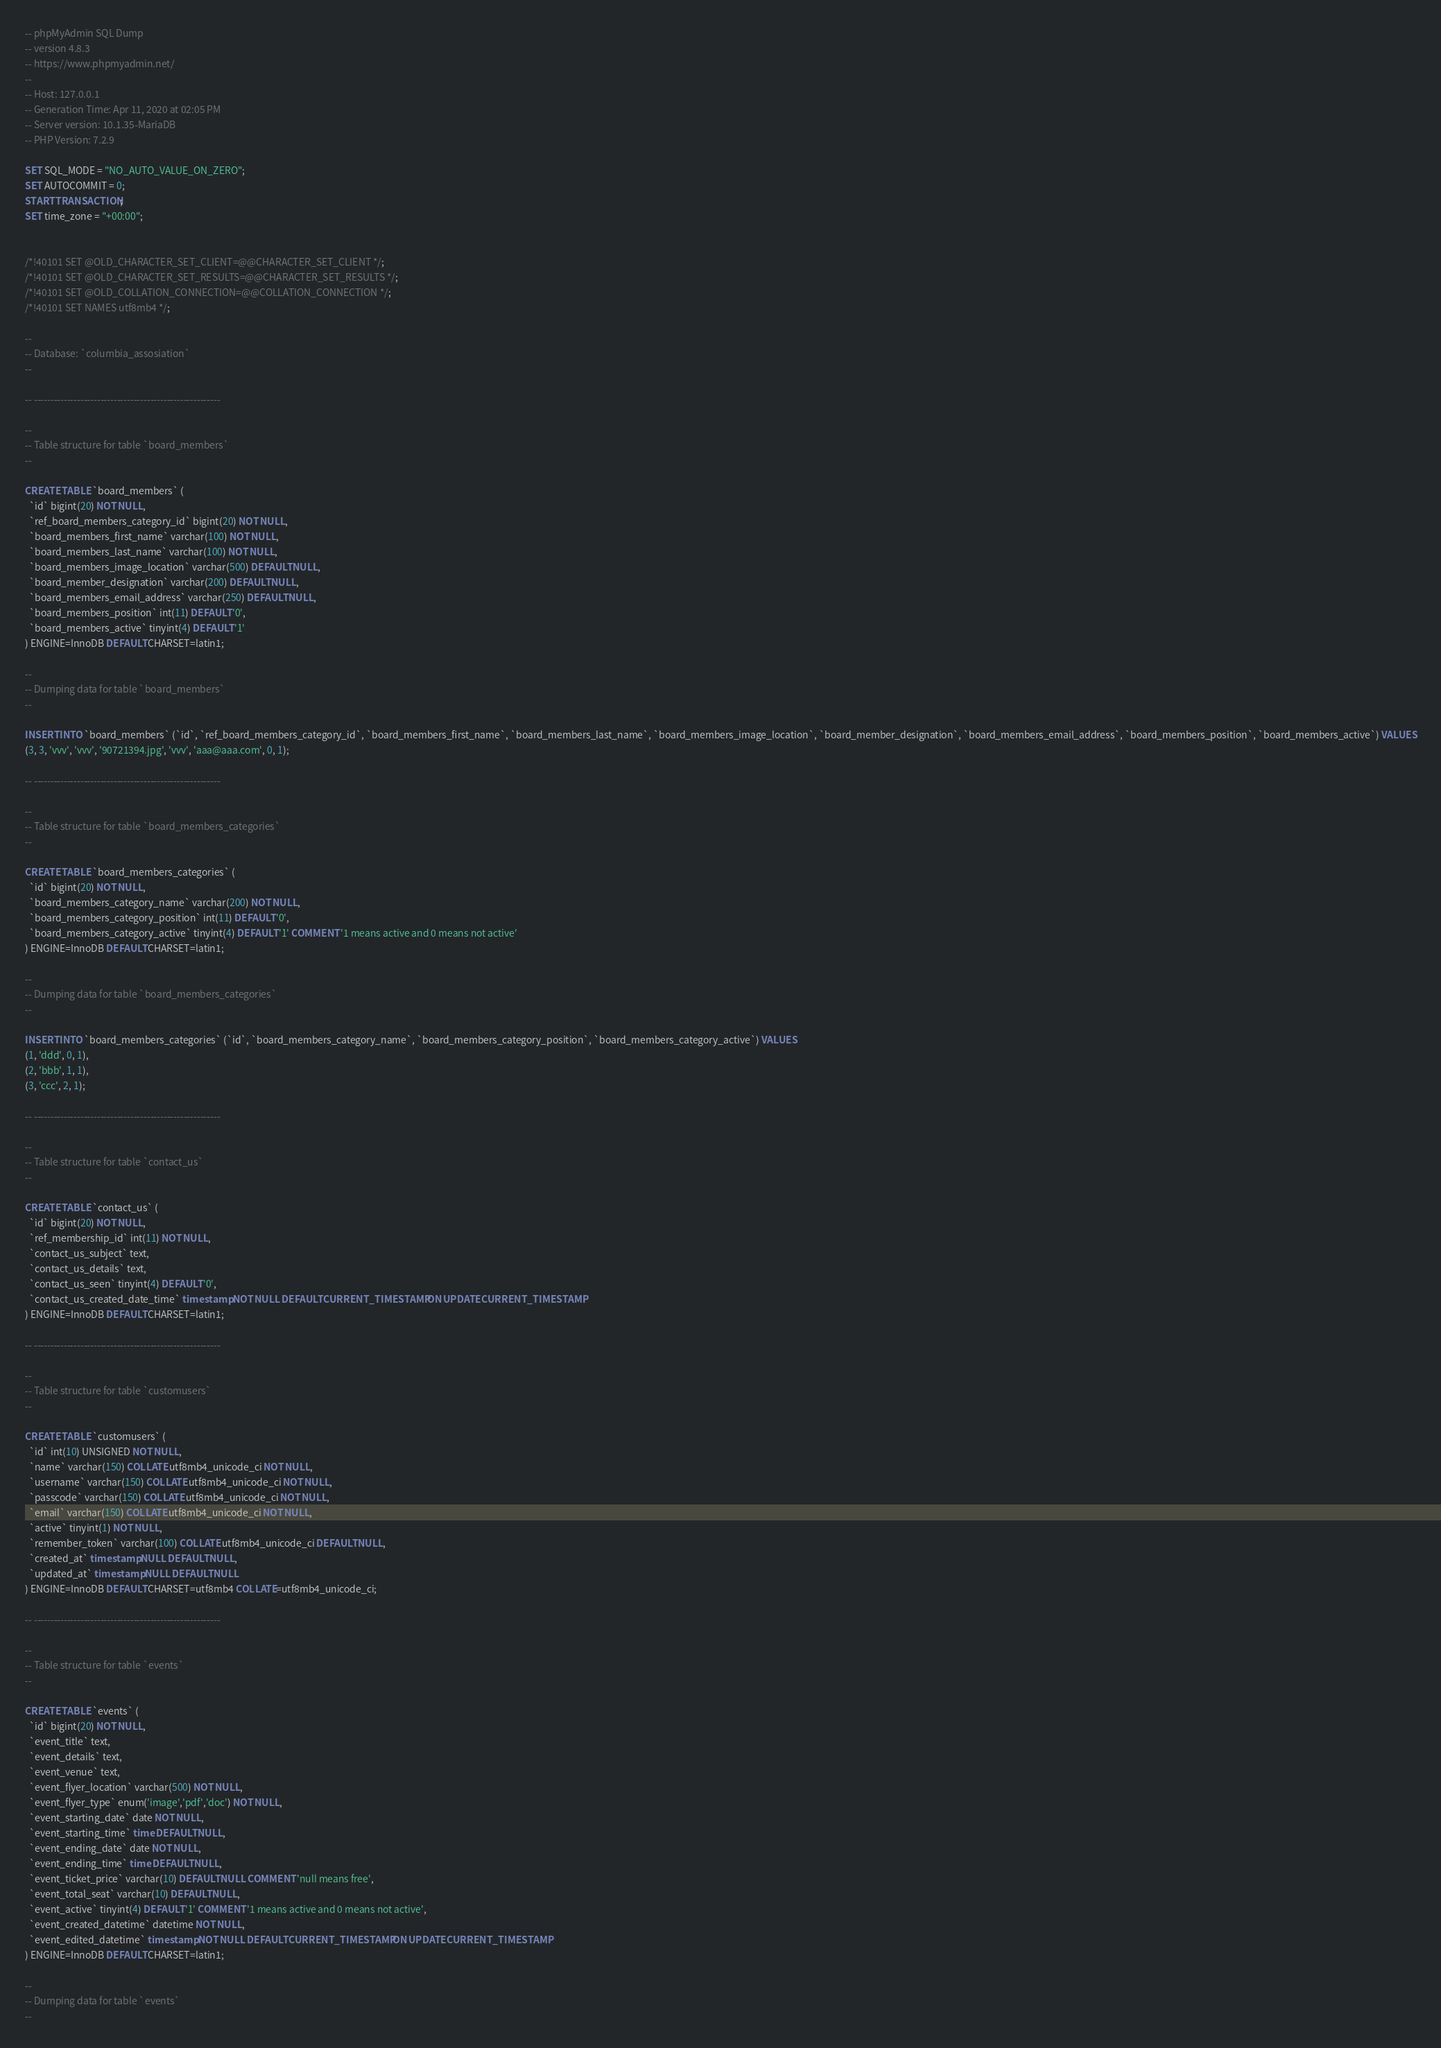Convert code to text. <code><loc_0><loc_0><loc_500><loc_500><_SQL_>-- phpMyAdmin SQL Dump
-- version 4.8.3
-- https://www.phpmyadmin.net/
--
-- Host: 127.0.0.1
-- Generation Time: Apr 11, 2020 at 02:05 PM
-- Server version: 10.1.35-MariaDB
-- PHP Version: 7.2.9

SET SQL_MODE = "NO_AUTO_VALUE_ON_ZERO";
SET AUTOCOMMIT = 0;
START TRANSACTION;
SET time_zone = "+00:00";


/*!40101 SET @OLD_CHARACTER_SET_CLIENT=@@CHARACTER_SET_CLIENT */;
/*!40101 SET @OLD_CHARACTER_SET_RESULTS=@@CHARACTER_SET_RESULTS */;
/*!40101 SET @OLD_COLLATION_CONNECTION=@@COLLATION_CONNECTION */;
/*!40101 SET NAMES utf8mb4 */;

--
-- Database: `columbia_assosiation`
--

-- --------------------------------------------------------

--
-- Table structure for table `board_members`
--

CREATE TABLE `board_members` (
  `id` bigint(20) NOT NULL,
  `ref_board_members_category_id` bigint(20) NOT NULL,
  `board_members_first_name` varchar(100) NOT NULL,
  `board_members_last_name` varchar(100) NOT NULL,
  `board_members_image_location` varchar(500) DEFAULT NULL,
  `board_member_designation` varchar(200) DEFAULT NULL,
  `board_members_email_address` varchar(250) DEFAULT NULL,
  `board_members_position` int(11) DEFAULT '0',
  `board_members_active` tinyint(4) DEFAULT '1'
) ENGINE=InnoDB DEFAULT CHARSET=latin1;

--
-- Dumping data for table `board_members`
--

INSERT INTO `board_members` (`id`, `ref_board_members_category_id`, `board_members_first_name`, `board_members_last_name`, `board_members_image_location`, `board_member_designation`, `board_members_email_address`, `board_members_position`, `board_members_active`) VALUES
(3, 3, 'vvv', 'vvv', '90721394.jpg', 'vvv', 'aaa@aaa.com', 0, 1);

-- --------------------------------------------------------

--
-- Table structure for table `board_members_categories`
--

CREATE TABLE `board_members_categories` (
  `id` bigint(20) NOT NULL,
  `board_members_category_name` varchar(200) NOT NULL,
  `board_members_category_position` int(11) DEFAULT '0',
  `board_members_category_active` tinyint(4) DEFAULT '1' COMMENT '1 means active and 0 means not active'
) ENGINE=InnoDB DEFAULT CHARSET=latin1;

--
-- Dumping data for table `board_members_categories`
--

INSERT INTO `board_members_categories` (`id`, `board_members_category_name`, `board_members_category_position`, `board_members_category_active`) VALUES
(1, 'ddd', 0, 1),
(2, 'bbb', 1, 1),
(3, 'ccc', 2, 1);

-- --------------------------------------------------------

--
-- Table structure for table `contact_us`
--

CREATE TABLE `contact_us` (
  `id` bigint(20) NOT NULL,
  `ref_membership_id` int(11) NOT NULL,
  `contact_us_subject` text,
  `contact_us_details` text,
  `contact_us_seen` tinyint(4) DEFAULT '0',
  `contact_us_created_date_time` timestamp NOT NULL DEFAULT CURRENT_TIMESTAMP ON UPDATE CURRENT_TIMESTAMP
) ENGINE=InnoDB DEFAULT CHARSET=latin1;

-- --------------------------------------------------------

--
-- Table structure for table `customusers`
--

CREATE TABLE `customusers` (
  `id` int(10) UNSIGNED NOT NULL,
  `name` varchar(150) COLLATE utf8mb4_unicode_ci NOT NULL,
  `username` varchar(150) COLLATE utf8mb4_unicode_ci NOT NULL,
  `passcode` varchar(150) COLLATE utf8mb4_unicode_ci NOT NULL,
  `email` varchar(150) COLLATE utf8mb4_unicode_ci NOT NULL,
  `active` tinyint(1) NOT NULL,
  `remember_token` varchar(100) COLLATE utf8mb4_unicode_ci DEFAULT NULL,
  `created_at` timestamp NULL DEFAULT NULL,
  `updated_at` timestamp NULL DEFAULT NULL
) ENGINE=InnoDB DEFAULT CHARSET=utf8mb4 COLLATE=utf8mb4_unicode_ci;

-- --------------------------------------------------------

--
-- Table structure for table `events`
--

CREATE TABLE `events` (
  `id` bigint(20) NOT NULL,
  `event_title` text,
  `event_details` text,
  `event_venue` text,
  `event_flyer_location` varchar(500) NOT NULL,
  `event_flyer_type` enum('image','pdf','doc') NOT NULL,
  `event_starting_date` date NOT NULL,
  `event_starting_time` time DEFAULT NULL,
  `event_ending_date` date NOT NULL,
  `event_ending_time` time DEFAULT NULL,
  `event_ticket_price` varchar(10) DEFAULT NULL COMMENT 'null means free',
  `event_total_seat` varchar(10) DEFAULT NULL,
  `event_active` tinyint(4) DEFAULT '1' COMMENT '1 means active and 0 means not active',
  `event_created_datetime` datetime NOT NULL,
  `event_edited_datetime` timestamp NOT NULL DEFAULT CURRENT_TIMESTAMP ON UPDATE CURRENT_TIMESTAMP
) ENGINE=InnoDB DEFAULT CHARSET=latin1;

--
-- Dumping data for table `events`
--
</code> 